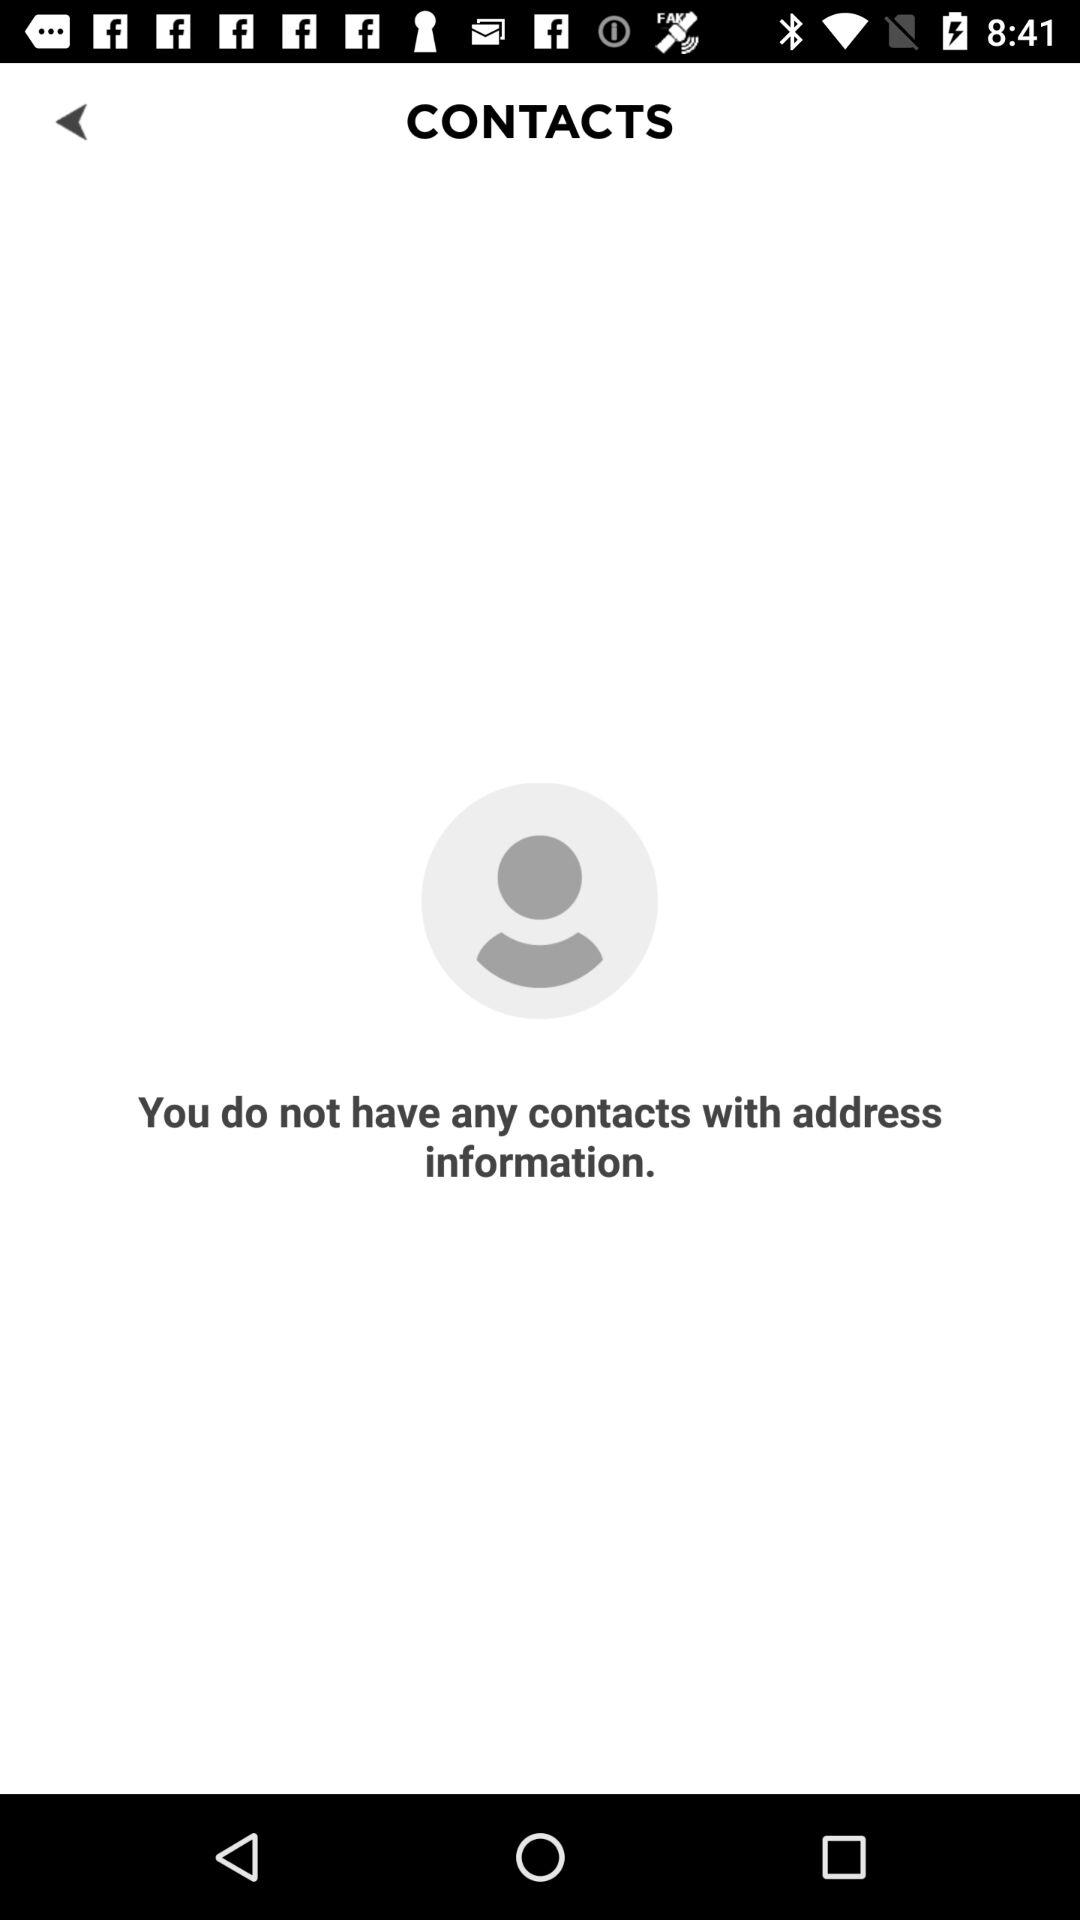How many contacts have address information?
Answer the question using a single word or phrase. 0 